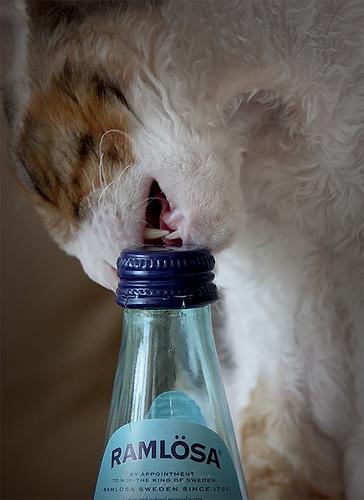Is this cat trying to open the bottle?
Short answer required. Yes. What animal is this?
Concise answer only. Cat. What is the brand of what the cat is trying to get open?
Give a very brief answer. Ramlosa. Is the cat afraid of the bottle?
Quick response, please. No. 